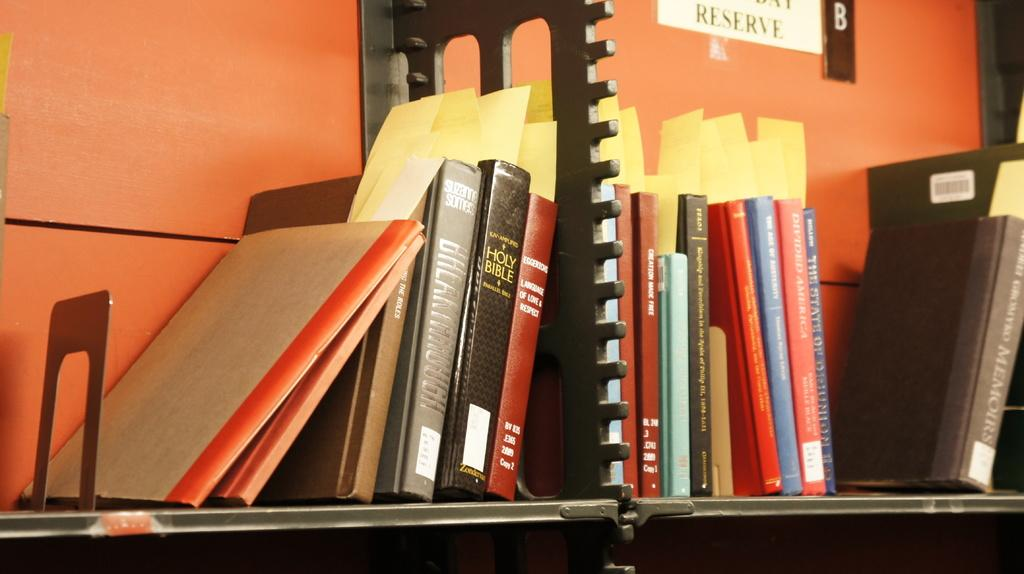<image>
Render a clear and concise summary of the photo. A Holy Bible is on a shelf with other books. 